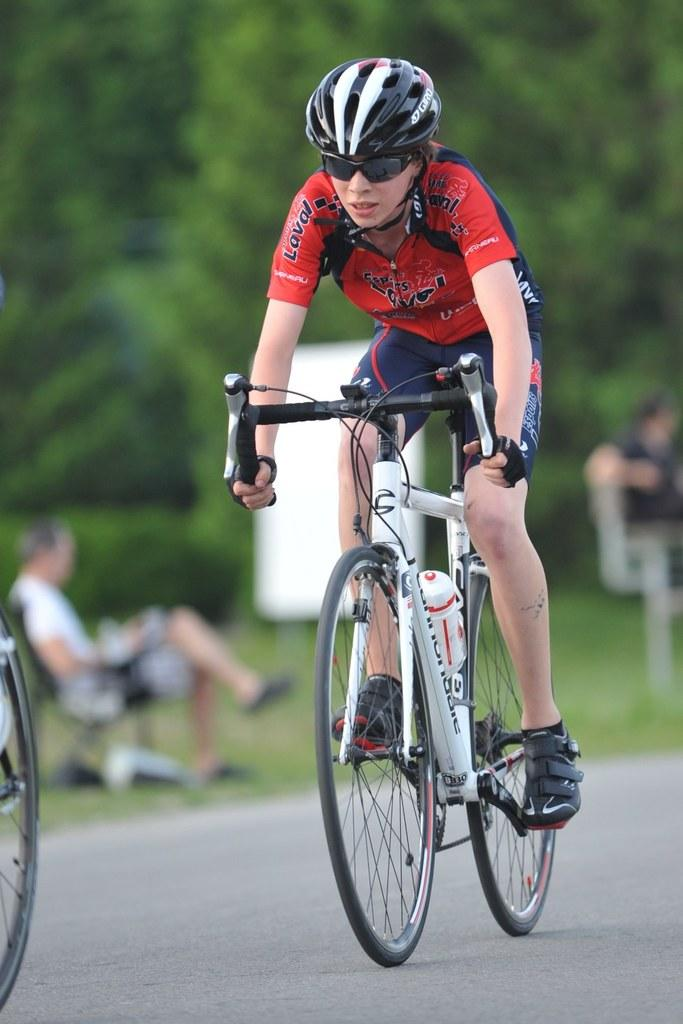What is happening in the foreground of the image? There is a person riding a bicycle in the foreground of the image. Can you describe the person on the left side of the image? There is a man sitting on the left side of the image. What can be seen in the background of the image? The background of the image includes trees. What type of legal advice is the man on the left side of the image providing in the image? There is no indication of a lawyer or any legal advice in the image; it simply shows a man sitting on the left side. What tool is the person riding the bicycle using to fix the bike in the image? There is no wrench or any tool visible in the image; it only shows a person riding a bicycle. 